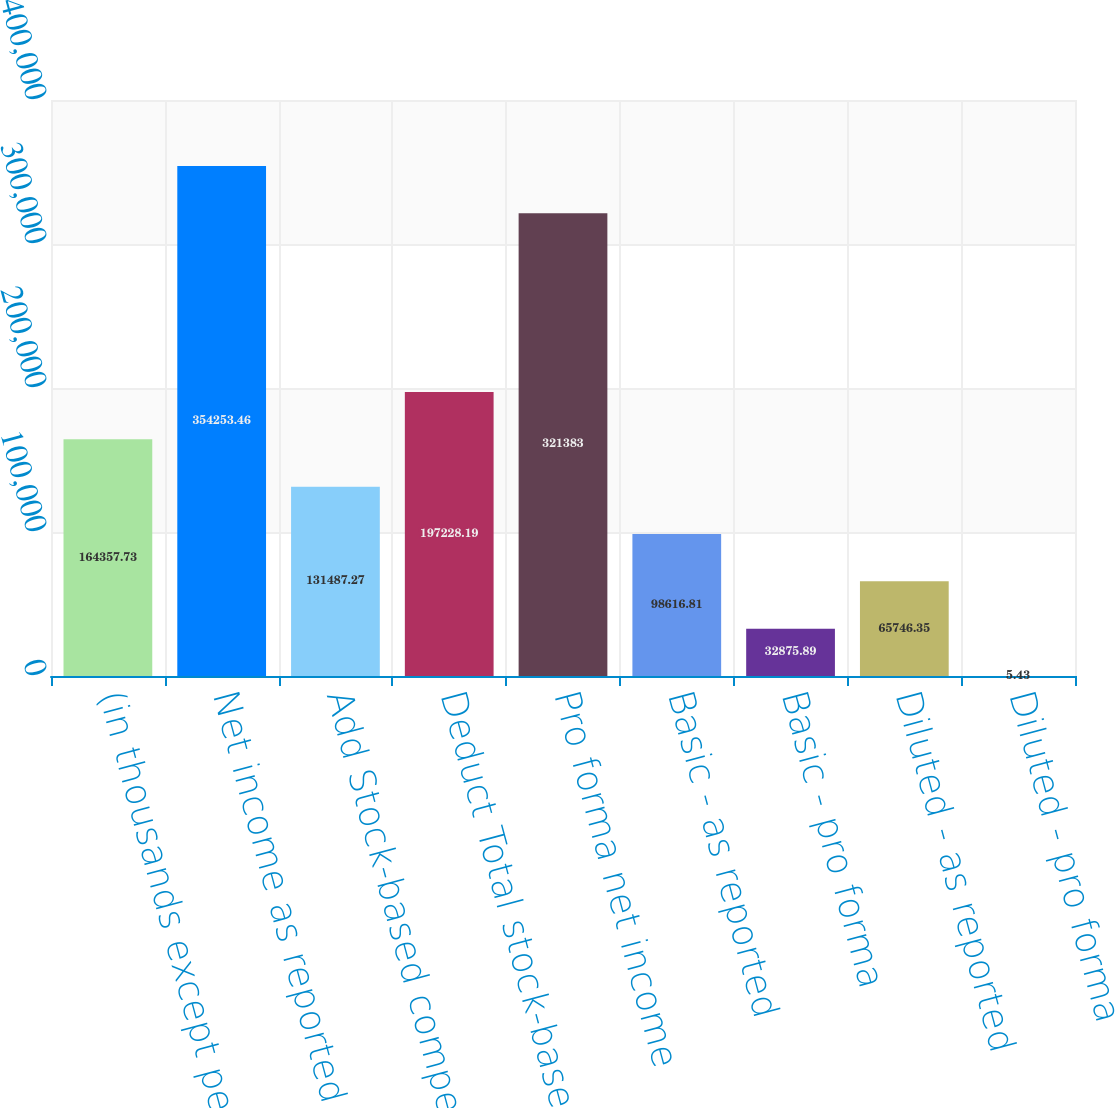Convert chart to OTSL. <chart><loc_0><loc_0><loc_500><loc_500><bar_chart><fcel>(in thousands except per share<fcel>Net income as reported<fcel>Add Stock-based compensation<fcel>Deduct Total stock-based<fcel>Pro forma net income<fcel>Basic - as reported<fcel>Basic - pro forma<fcel>Diluted - as reported<fcel>Diluted - pro forma<nl><fcel>164358<fcel>354253<fcel>131487<fcel>197228<fcel>321383<fcel>98616.8<fcel>32875.9<fcel>65746.4<fcel>5.43<nl></chart> 